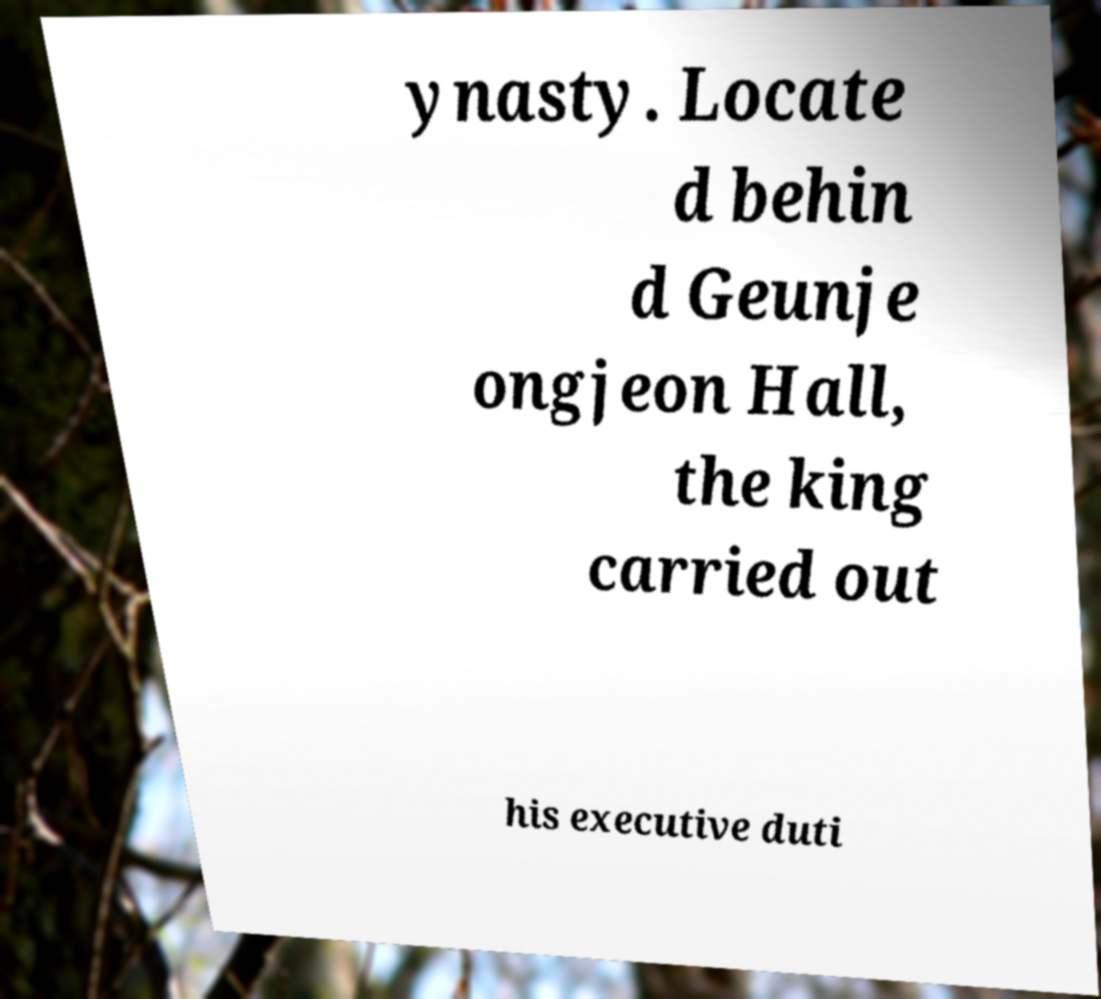Please read and relay the text visible in this image. What does it say? ynasty. Locate d behin d Geunje ongjeon Hall, the king carried out his executive duti 